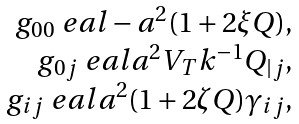Convert formula to latex. <formula><loc_0><loc_0><loc_500><loc_500>\begin{array} { r c l } g _ { 0 0 } \ e a l - a ^ { 2 } ( 1 + 2 \xi Q ) , \\ g _ { 0 j } \ e a l a ^ { 2 } V _ { T } k ^ { - 1 } Q _ { | j } , \\ g _ { i j } \ e a l a ^ { 2 } ( 1 + 2 \zeta Q ) \gamma _ { i j } , \end{array}</formula> 